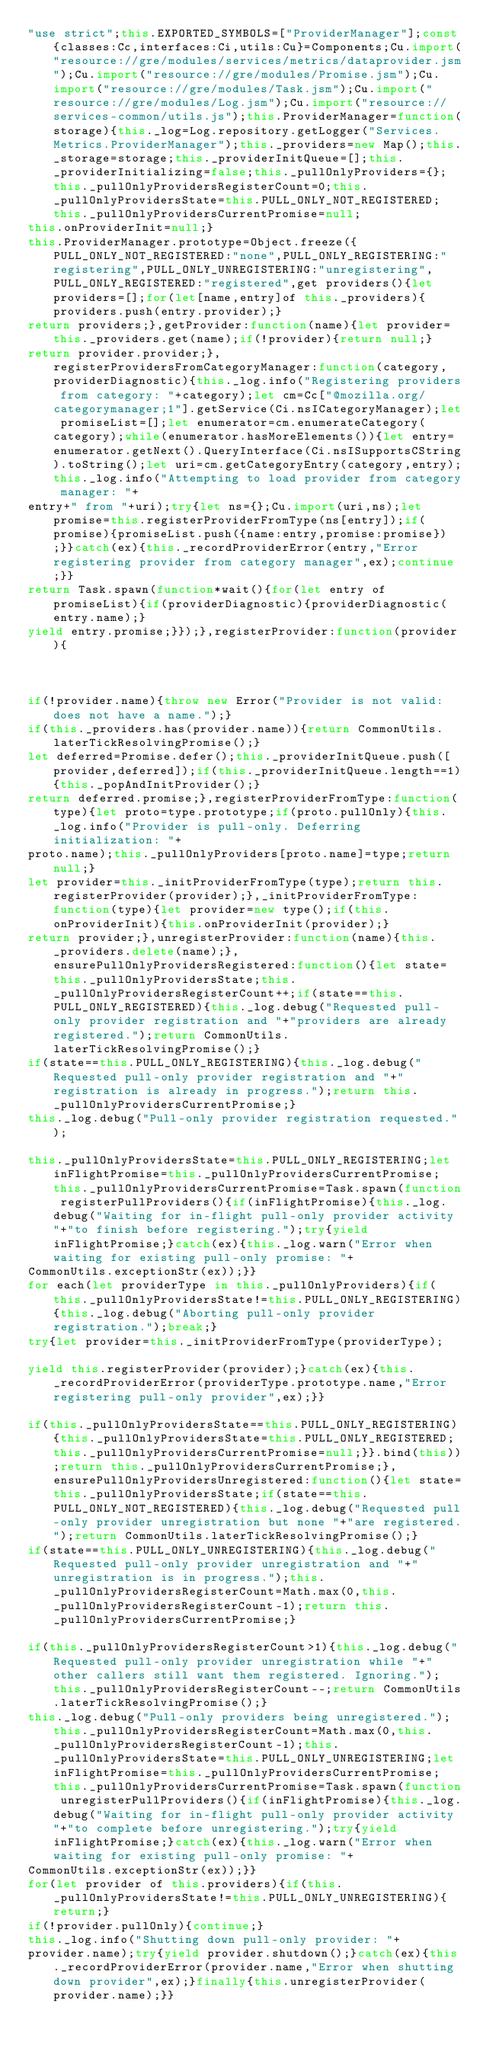<code> <loc_0><loc_0><loc_500><loc_500><_JavaScript_>"use strict";this.EXPORTED_SYMBOLS=["ProviderManager"];const{classes:Cc,interfaces:Ci,utils:Cu}=Components;Cu.import("resource://gre/modules/services/metrics/dataprovider.jsm");Cu.import("resource://gre/modules/Promise.jsm");Cu.import("resource://gre/modules/Task.jsm");Cu.import("resource://gre/modules/Log.jsm");Cu.import("resource://services-common/utils.js");this.ProviderManager=function(storage){this._log=Log.repository.getLogger("Services.Metrics.ProviderManager");this._providers=new Map();this._storage=storage;this._providerInitQueue=[];this._providerInitializing=false;this._pullOnlyProviders={};this._pullOnlyProvidersRegisterCount=0;this._pullOnlyProvidersState=this.PULL_ONLY_NOT_REGISTERED;this._pullOnlyProvidersCurrentPromise=null;
this.onProviderInit=null;}
this.ProviderManager.prototype=Object.freeze({PULL_ONLY_NOT_REGISTERED:"none",PULL_ONLY_REGISTERING:"registering",PULL_ONLY_UNREGISTERING:"unregistering",PULL_ONLY_REGISTERED:"registered",get providers(){let providers=[];for(let[name,entry]of this._providers){providers.push(entry.provider);}
return providers;},getProvider:function(name){let provider=this._providers.get(name);if(!provider){return null;}
return provider.provider;},registerProvidersFromCategoryManager:function(category,providerDiagnostic){this._log.info("Registering providers from category: "+category);let cm=Cc["@mozilla.org/categorymanager;1"].getService(Ci.nsICategoryManager);let promiseList=[];let enumerator=cm.enumerateCategory(category);while(enumerator.hasMoreElements()){let entry=enumerator.getNext().QueryInterface(Ci.nsISupportsCString).toString();let uri=cm.getCategoryEntry(category,entry);this._log.info("Attempting to load provider from category manager: "+
entry+" from "+uri);try{let ns={};Cu.import(uri,ns);let promise=this.registerProviderFromType(ns[entry]);if(promise){promiseList.push({name:entry,promise:promise});}}catch(ex){this._recordProviderError(entry,"Error registering provider from category manager",ex);continue;}}
return Task.spawn(function*wait(){for(let entry of promiseList){if(providerDiagnostic){providerDiagnostic(entry.name);}
yield entry.promise;}});},registerProvider:function(provider){



if(!provider.name){throw new Error("Provider is not valid: does not have a name.");}
if(this._providers.has(provider.name)){return CommonUtils.laterTickResolvingPromise();}
let deferred=Promise.defer();this._providerInitQueue.push([provider,deferred]);if(this._providerInitQueue.length==1){this._popAndInitProvider();}
return deferred.promise;},registerProviderFromType:function(type){let proto=type.prototype;if(proto.pullOnly){this._log.info("Provider is pull-only. Deferring initialization: "+
proto.name);this._pullOnlyProviders[proto.name]=type;return null;}
let provider=this._initProviderFromType(type);return this.registerProvider(provider);},_initProviderFromType:function(type){let provider=new type();if(this.onProviderInit){this.onProviderInit(provider);}
return provider;},unregisterProvider:function(name){this._providers.delete(name);},ensurePullOnlyProvidersRegistered:function(){let state=this._pullOnlyProvidersState;this._pullOnlyProvidersRegisterCount++;if(state==this.PULL_ONLY_REGISTERED){this._log.debug("Requested pull-only provider registration and "+"providers are already registered.");return CommonUtils.laterTickResolvingPromise();}
if(state==this.PULL_ONLY_REGISTERING){this._log.debug("Requested pull-only provider registration and "+"registration is already in progress.");return this._pullOnlyProvidersCurrentPromise;}
this._log.debug("Pull-only provider registration requested.");

this._pullOnlyProvidersState=this.PULL_ONLY_REGISTERING;let inFlightPromise=this._pullOnlyProvidersCurrentPromise;this._pullOnlyProvidersCurrentPromise=Task.spawn(function registerPullProviders(){if(inFlightPromise){this._log.debug("Waiting for in-flight pull-only provider activity "+"to finish before registering.");try{yield inFlightPromise;}catch(ex){this._log.warn("Error when waiting for existing pull-only promise: "+
CommonUtils.exceptionStr(ex));}}
for each(let providerType in this._pullOnlyProviders){if(this._pullOnlyProvidersState!=this.PULL_ONLY_REGISTERING){this._log.debug("Aborting pull-only provider registration.");break;}
try{let provider=this._initProviderFromType(providerType);

yield this.registerProvider(provider);}catch(ex){this._recordProviderError(providerType.prototype.name,"Error registering pull-only provider",ex);}}

if(this._pullOnlyProvidersState==this.PULL_ONLY_REGISTERING){this._pullOnlyProvidersState=this.PULL_ONLY_REGISTERED;this._pullOnlyProvidersCurrentPromise=null;}}.bind(this));return this._pullOnlyProvidersCurrentPromise;},ensurePullOnlyProvidersUnregistered:function(){let state=this._pullOnlyProvidersState;if(state==this.PULL_ONLY_NOT_REGISTERED){this._log.debug("Requested pull-only provider unregistration but none "+"are registered.");return CommonUtils.laterTickResolvingPromise();}
if(state==this.PULL_ONLY_UNREGISTERING){this._log.debug("Requested pull-only provider unregistration and "+"unregistration is in progress.");this._pullOnlyProvidersRegisterCount=Math.max(0,this._pullOnlyProvidersRegisterCount-1);return this._pullOnlyProvidersCurrentPromise;}

if(this._pullOnlyProvidersRegisterCount>1){this._log.debug("Requested pull-only provider unregistration while "+"other callers still want them registered. Ignoring.");this._pullOnlyProvidersRegisterCount--;return CommonUtils.laterTickResolvingPromise();}
this._log.debug("Pull-only providers being unregistered.");this._pullOnlyProvidersRegisterCount=Math.max(0,this._pullOnlyProvidersRegisterCount-1);this._pullOnlyProvidersState=this.PULL_ONLY_UNREGISTERING;let inFlightPromise=this._pullOnlyProvidersCurrentPromise;this._pullOnlyProvidersCurrentPromise=Task.spawn(function unregisterPullProviders(){if(inFlightPromise){this._log.debug("Waiting for in-flight pull-only provider activity "+"to complete before unregistering.");try{yield inFlightPromise;}catch(ex){this._log.warn("Error when waiting for existing pull-only promise: "+
CommonUtils.exceptionStr(ex));}}
for(let provider of this.providers){if(this._pullOnlyProvidersState!=this.PULL_ONLY_UNREGISTERING){return;}
if(!provider.pullOnly){continue;}
this._log.info("Shutting down pull-only provider: "+
provider.name);try{yield provider.shutdown();}catch(ex){this._recordProviderError(provider.name,"Error when shutting down provider",ex);}finally{this.unregisterProvider(provider.name);}}</code> 